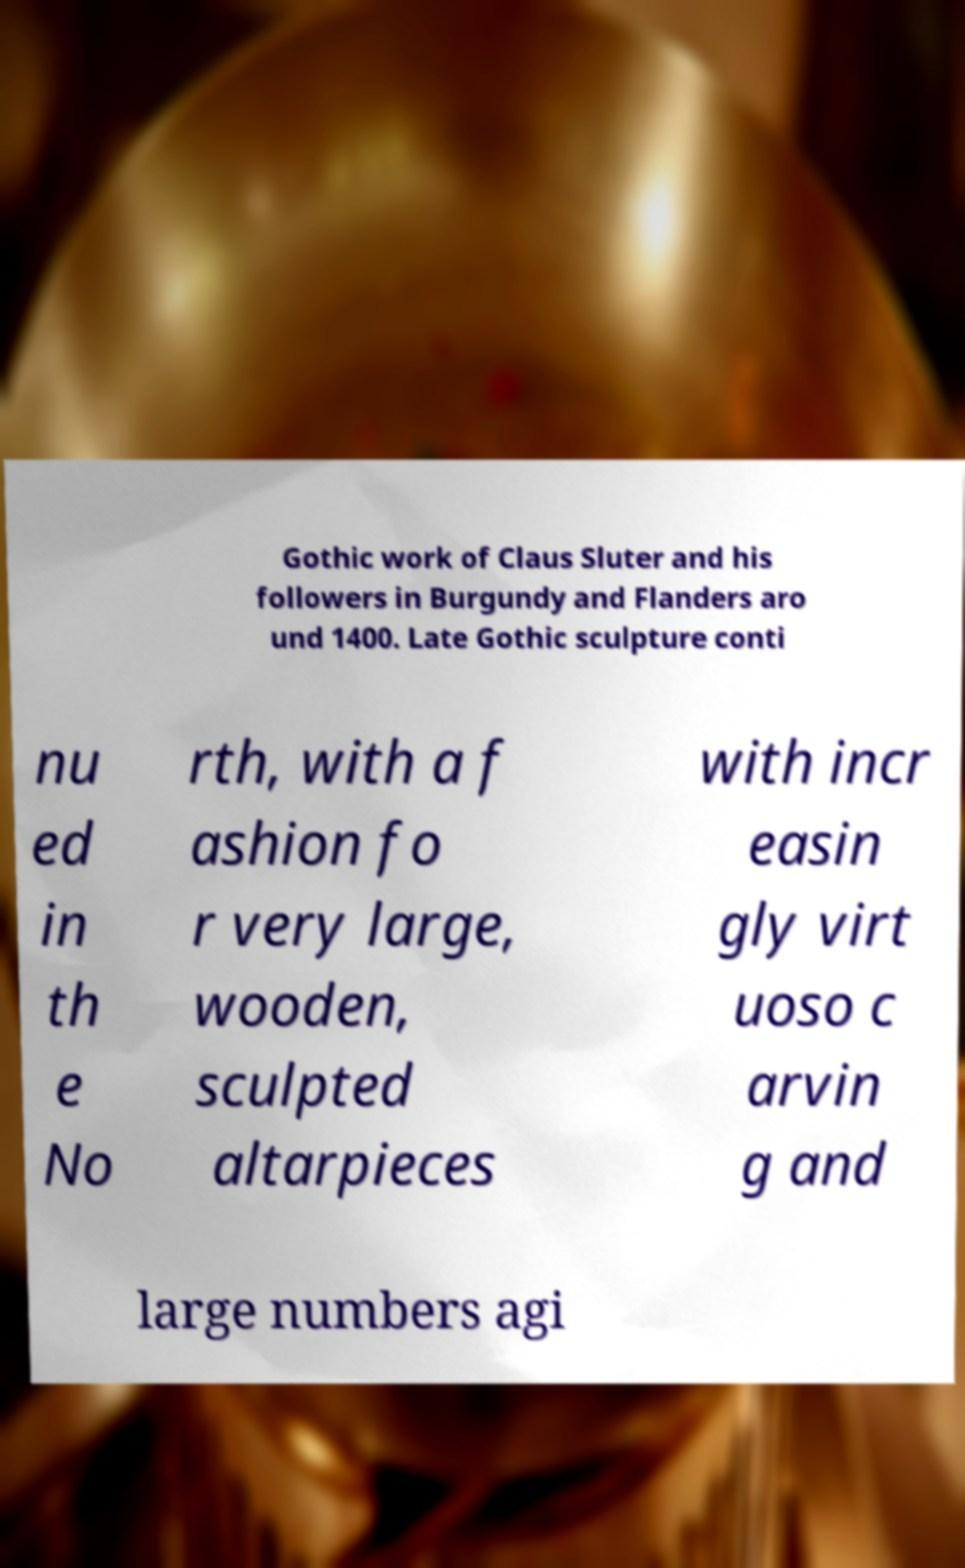There's text embedded in this image that I need extracted. Can you transcribe it verbatim? Gothic work of Claus Sluter and his followers in Burgundy and Flanders aro und 1400. Late Gothic sculpture conti nu ed in th e No rth, with a f ashion fo r very large, wooden, sculpted altarpieces with incr easin gly virt uoso c arvin g and large numbers agi 